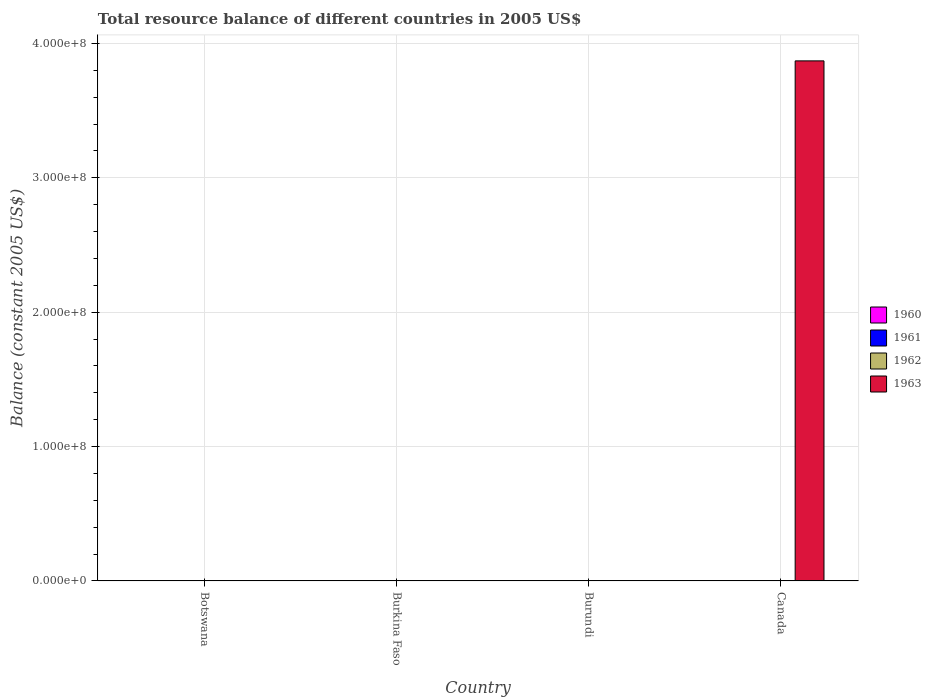How many different coloured bars are there?
Give a very brief answer. 1. Are the number of bars per tick equal to the number of legend labels?
Provide a succinct answer. No. How many bars are there on the 3rd tick from the right?
Your answer should be compact. 0. What is the label of the 2nd group of bars from the left?
Your answer should be compact. Burkina Faso. Across all countries, what is the maximum total resource balance in 1963?
Offer a terse response. 3.87e+08. What is the total total resource balance in 1962 in the graph?
Offer a very short reply. 0. What is the difference between the total resource balance in 1960 in Canada and the total resource balance in 1962 in Botswana?
Give a very brief answer. 0. What is the average total resource balance in 1960 per country?
Your answer should be compact. 0. In how many countries, is the total resource balance in 1963 greater than 200000000 US$?
Offer a terse response. 1. What is the difference between the highest and the lowest total resource balance in 1963?
Keep it short and to the point. 3.87e+08. How many bars are there?
Your answer should be compact. 1. How many countries are there in the graph?
Your answer should be very brief. 4. What is the difference between two consecutive major ticks on the Y-axis?
Keep it short and to the point. 1.00e+08. Are the values on the major ticks of Y-axis written in scientific E-notation?
Your answer should be compact. Yes. Does the graph contain grids?
Provide a succinct answer. Yes. Where does the legend appear in the graph?
Provide a short and direct response. Center right. What is the title of the graph?
Your answer should be compact. Total resource balance of different countries in 2005 US$. Does "1979" appear as one of the legend labels in the graph?
Offer a very short reply. No. What is the label or title of the X-axis?
Offer a terse response. Country. What is the label or title of the Y-axis?
Your answer should be very brief. Balance (constant 2005 US$). What is the Balance (constant 2005 US$) in 1960 in Botswana?
Ensure brevity in your answer.  0. What is the Balance (constant 2005 US$) in 1963 in Botswana?
Provide a succinct answer. 0. What is the Balance (constant 2005 US$) of 1960 in Burkina Faso?
Your response must be concise. 0. What is the Balance (constant 2005 US$) of 1961 in Burkina Faso?
Provide a short and direct response. 0. What is the Balance (constant 2005 US$) of 1960 in Burundi?
Ensure brevity in your answer.  0. What is the Balance (constant 2005 US$) of 1961 in Burundi?
Give a very brief answer. 0. What is the Balance (constant 2005 US$) of 1962 in Burundi?
Offer a very short reply. 0. What is the Balance (constant 2005 US$) of 1961 in Canada?
Give a very brief answer. 0. What is the Balance (constant 2005 US$) in 1962 in Canada?
Your answer should be compact. 0. What is the Balance (constant 2005 US$) in 1963 in Canada?
Keep it short and to the point. 3.87e+08. Across all countries, what is the maximum Balance (constant 2005 US$) in 1963?
Make the answer very short. 3.87e+08. Across all countries, what is the minimum Balance (constant 2005 US$) of 1963?
Give a very brief answer. 0. What is the total Balance (constant 2005 US$) in 1960 in the graph?
Make the answer very short. 0. What is the total Balance (constant 2005 US$) of 1962 in the graph?
Your answer should be compact. 0. What is the total Balance (constant 2005 US$) in 1963 in the graph?
Ensure brevity in your answer.  3.87e+08. What is the average Balance (constant 2005 US$) in 1960 per country?
Offer a terse response. 0. What is the average Balance (constant 2005 US$) of 1961 per country?
Keep it short and to the point. 0. What is the average Balance (constant 2005 US$) in 1962 per country?
Ensure brevity in your answer.  0. What is the average Balance (constant 2005 US$) in 1963 per country?
Give a very brief answer. 9.68e+07. What is the difference between the highest and the lowest Balance (constant 2005 US$) of 1963?
Your response must be concise. 3.87e+08. 